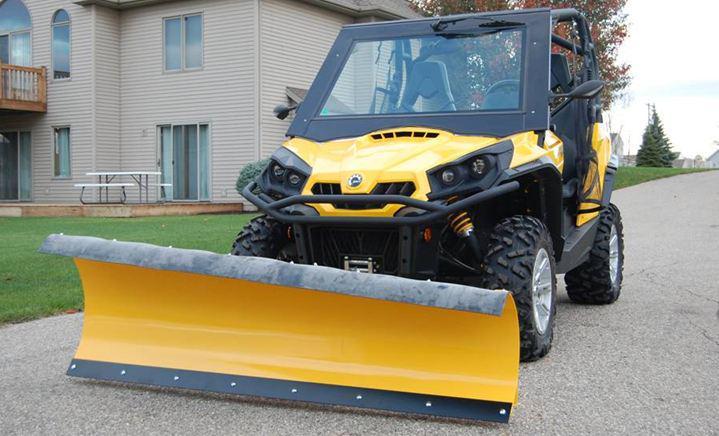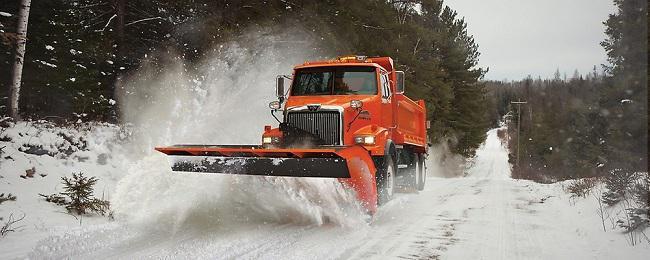The first image is the image on the left, the second image is the image on the right. Analyze the images presented: Is the assertion "There are no fewer than 4 vehicles on the road." valid? Answer yes or no. No. The first image is the image on the left, the second image is the image on the right. Examine the images to the left and right. Is the description "The left and right image contains a total of three snow trucks." accurate? Answer yes or no. No. 